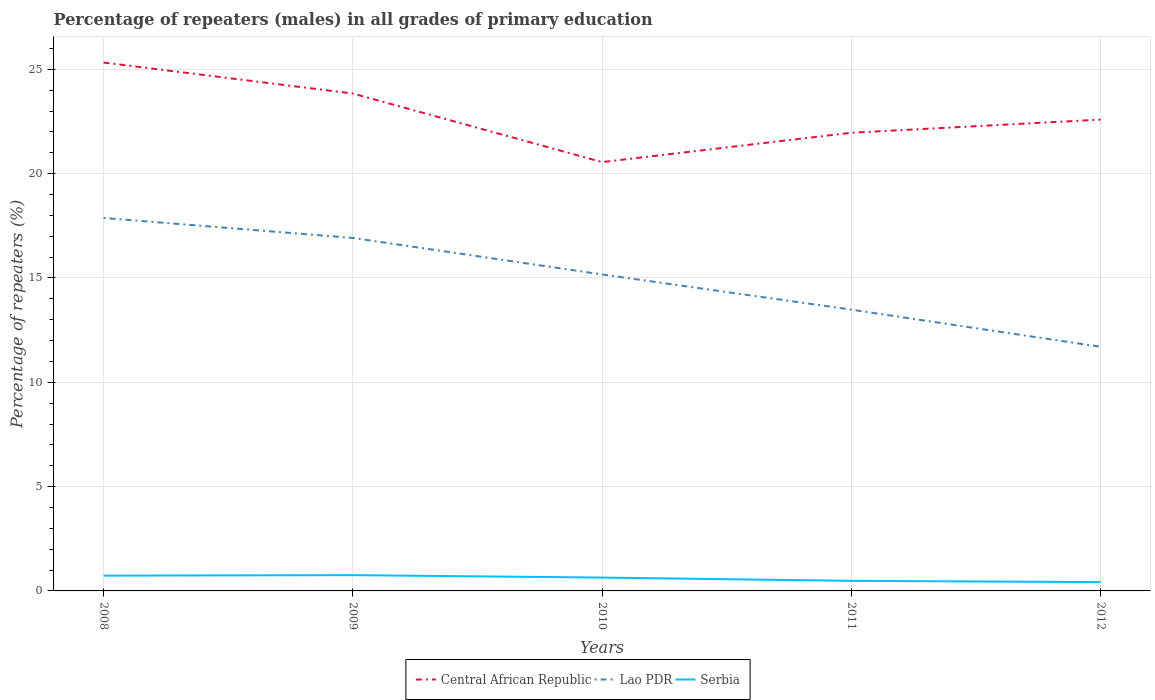Is the number of lines equal to the number of legend labels?
Give a very brief answer. Yes. Across all years, what is the maximum percentage of repeaters (males) in Lao PDR?
Keep it short and to the point. 11.7. What is the total percentage of repeaters (males) in Central African Republic in the graph?
Give a very brief answer. -2.04. What is the difference between the highest and the second highest percentage of repeaters (males) in Central African Republic?
Provide a succinct answer. 4.77. How many lines are there?
Ensure brevity in your answer.  3. How many years are there in the graph?
Offer a very short reply. 5. Are the values on the major ticks of Y-axis written in scientific E-notation?
Give a very brief answer. No. Does the graph contain any zero values?
Ensure brevity in your answer.  No. Does the graph contain grids?
Offer a terse response. Yes. How many legend labels are there?
Offer a terse response. 3. What is the title of the graph?
Make the answer very short. Percentage of repeaters (males) in all grades of primary education. What is the label or title of the X-axis?
Provide a short and direct response. Years. What is the label or title of the Y-axis?
Your answer should be compact. Percentage of repeaters (%). What is the Percentage of repeaters (%) in Central African Republic in 2008?
Offer a very short reply. 25.33. What is the Percentage of repeaters (%) of Lao PDR in 2008?
Give a very brief answer. 17.88. What is the Percentage of repeaters (%) in Serbia in 2008?
Provide a short and direct response. 0.73. What is the Percentage of repeaters (%) of Central African Republic in 2009?
Offer a very short reply. 23.84. What is the Percentage of repeaters (%) of Lao PDR in 2009?
Your response must be concise. 16.92. What is the Percentage of repeaters (%) in Serbia in 2009?
Ensure brevity in your answer.  0.76. What is the Percentage of repeaters (%) in Central African Republic in 2010?
Give a very brief answer. 20.56. What is the Percentage of repeaters (%) in Lao PDR in 2010?
Offer a very short reply. 15.17. What is the Percentage of repeaters (%) in Serbia in 2010?
Provide a succinct answer. 0.64. What is the Percentage of repeaters (%) in Central African Republic in 2011?
Your answer should be very brief. 21.96. What is the Percentage of repeaters (%) of Lao PDR in 2011?
Offer a very short reply. 13.48. What is the Percentage of repeaters (%) of Serbia in 2011?
Make the answer very short. 0.48. What is the Percentage of repeaters (%) of Central African Republic in 2012?
Your response must be concise. 22.59. What is the Percentage of repeaters (%) in Lao PDR in 2012?
Offer a terse response. 11.7. What is the Percentage of repeaters (%) in Serbia in 2012?
Provide a short and direct response. 0.42. Across all years, what is the maximum Percentage of repeaters (%) of Central African Republic?
Provide a succinct answer. 25.33. Across all years, what is the maximum Percentage of repeaters (%) in Lao PDR?
Your answer should be very brief. 17.88. Across all years, what is the maximum Percentage of repeaters (%) of Serbia?
Your response must be concise. 0.76. Across all years, what is the minimum Percentage of repeaters (%) in Central African Republic?
Your answer should be compact. 20.56. Across all years, what is the minimum Percentage of repeaters (%) in Lao PDR?
Provide a short and direct response. 11.7. Across all years, what is the minimum Percentage of repeaters (%) of Serbia?
Provide a succinct answer. 0.42. What is the total Percentage of repeaters (%) of Central African Republic in the graph?
Your answer should be compact. 114.28. What is the total Percentage of repeaters (%) in Lao PDR in the graph?
Offer a very short reply. 75.15. What is the total Percentage of repeaters (%) of Serbia in the graph?
Provide a succinct answer. 3.03. What is the difference between the Percentage of repeaters (%) in Central African Republic in 2008 and that in 2009?
Offer a terse response. 1.48. What is the difference between the Percentage of repeaters (%) of Serbia in 2008 and that in 2009?
Offer a very short reply. -0.02. What is the difference between the Percentage of repeaters (%) of Central African Republic in 2008 and that in 2010?
Make the answer very short. 4.77. What is the difference between the Percentage of repeaters (%) in Lao PDR in 2008 and that in 2010?
Offer a very short reply. 2.71. What is the difference between the Percentage of repeaters (%) of Serbia in 2008 and that in 2010?
Provide a succinct answer. 0.09. What is the difference between the Percentage of repeaters (%) of Central African Republic in 2008 and that in 2011?
Your answer should be compact. 3.36. What is the difference between the Percentage of repeaters (%) of Lao PDR in 2008 and that in 2011?
Ensure brevity in your answer.  4.39. What is the difference between the Percentage of repeaters (%) of Serbia in 2008 and that in 2011?
Ensure brevity in your answer.  0.25. What is the difference between the Percentage of repeaters (%) of Central African Republic in 2008 and that in 2012?
Make the answer very short. 2.73. What is the difference between the Percentage of repeaters (%) of Lao PDR in 2008 and that in 2012?
Your answer should be compact. 6.18. What is the difference between the Percentage of repeaters (%) of Serbia in 2008 and that in 2012?
Offer a very short reply. 0.31. What is the difference between the Percentage of repeaters (%) of Central African Republic in 2009 and that in 2010?
Give a very brief answer. 3.29. What is the difference between the Percentage of repeaters (%) in Lao PDR in 2009 and that in 2010?
Keep it short and to the point. 1.75. What is the difference between the Percentage of repeaters (%) of Serbia in 2009 and that in 2010?
Make the answer very short. 0.12. What is the difference between the Percentage of repeaters (%) of Central African Republic in 2009 and that in 2011?
Make the answer very short. 1.88. What is the difference between the Percentage of repeaters (%) in Lao PDR in 2009 and that in 2011?
Keep it short and to the point. 3.44. What is the difference between the Percentage of repeaters (%) in Serbia in 2009 and that in 2011?
Offer a very short reply. 0.27. What is the difference between the Percentage of repeaters (%) of Central African Republic in 2009 and that in 2012?
Provide a succinct answer. 1.25. What is the difference between the Percentage of repeaters (%) in Lao PDR in 2009 and that in 2012?
Provide a short and direct response. 5.22. What is the difference between the Percentage of repeaters (%) of Serbia in 2009 and that in 2012?
Your answer should be compact. 0.33. What is the difference between the Percentage of repeaters (%) of Central African Republic in 2010 and that in 2011?
Ensure brevity in your answer.  -1.41. What is the difference between the Percentage of repeaters (%) of Lao PDR in 2010 and that in 2011?
Provide a succinct answer. 1.69. What is the difference between the Percentage of repeaters (%) in Serbia in 2010 and that in 2011?
Give a very brief answer. 0.16. What is the difference between the Percentage of repeaters (%) of Central African Republic in 2010 and that in 2012?
Offer a very short reply. -2.04. What is the difference between the Percentage of repeaters (%) of Lao PDR in 2010 and that in 2012?
Your answer should be very brief. 3.47. What is the difference between the Percentage of repeaters (%) of Serbia in 2010 and that in 2012?
Your answer should be very brief. 0.22. What is the difference between the Percentage of repeaters (%) in Central African Republic in 2011 and that in 2012?
Your answer should be compact. -0.63. What is the difference between the Percentage of repeaters (%) of Lao PDR in 2011 and that in 2012?
Offer a terse response. 1.78. What is the difference between the Percentage of repeaters (%) of Serbia in 2011 and that in 2012?
Make the answer very short. 0.06. What is the difference between the Percentage of repeaters (%) in Central African Republic in 2008 and the Percentage of repeaters (%) in Lao PDR in 2009?
Ensure brevity in your answer.  8.41. What is the difference between the Percentage of repeaters (%) of Central African Republic in 2008 and the Percentage of repeaters (%) of Serbia in 2009?
Provide a short and direct response. 24.57. What is the difference between the Percentage of repeaters (%) of Lao PDR in 2008 and the Percentage of repeaters (%) of Serbia in 2009?
Your answer should be very brief. 17.12. What is the difference between the Percentage of repeaters (%) of Central African Republic in 2008 and the Percentage of repeaters (%) of Lao PDR in 2010?
Make the answer very short. 10.16. What is the difference between the Percentage of repeaters (%) in Central African Republic in 2008 and the Percentage of repeaters (%) in Serbia in 2010?
Provide a short and direct response. 24.69. What is the difference between the Percentage of repeaters (%) in Lao PDR in 2008 and the Percentage of repeaters (%) in Serbia in 2010?
Offer a terse response. 17.24. What is the difference between the Percentage of repeaters (%) in Central African Republic in 2008 and the Percentage of repeaters (%) in Lao PDR in 2011?
Offer a very short reply. 11.84. What is the difference between the Percentage of repeaters (%) of Central African Republic in 2008 and the Percentage of repeaters (%) of Serbia in 2011?
Make the answer very short. 24.84. What is the difference between the Percentage of repeaters (%) in Lao PDR in 2008 and the Percentage of repeaters (%) in Serbia in 2011?
Provide a succinct answer. 17.39. What is the difference between the Percentage of repeaters (%) in Central African Republic in 2008 and the Percentage of repeaters (%) in Lao PDR in 2012?
Your response must be concise. 13.62. What is the difference between the Percentage of repeaters (%) in Central African Republic in 2008 and the Percentage of repeaters (%) in Serbia in 2012?
Offer a very short reply. 24.9. What is the difference between the Percentage of repeaters (%) in Lao PDR in 2008 and the Percentage of repeaters (%) in Serbia in 2012?
Ensure brevity in your answer.  17.46. What is the difference between the Percentage of repeaters (%) of Central African Republic in 2009 and the Percentage of repeaters (%) of Lao PDR in 2010?
Your answer should be compact. 8.67. What is the difference between the Percentage of repeaters (%) of Central African Republic in 2009 and the Percentage of repeaters (%) of Serbia in 2010?
Your answer should be very brief. 23.2. What is the difference between the Percentage of repeaters (%) in Lao PDR in 2009 and the Percentage of repeaters (%) in Serbia in 2010?
Your answer should be very brief. 16.28. What is the difference between the Percentage of repeaters (%) of Central African Republic in 2009 and the Percentage of repeaters (%) of Lao PDR in 2011?
Provide a succinct answer. 10.36. What is the difference between the Percentage of repeaters (%) of Central African Republic in 2009 and the Percentage of repeaters (%) of Serbia in 2011?
Provide a short and direct response. 23.36. What is the difference between the Percentage of repeaters (%) in Lao PDR in 2009 and the Percentage of repeaters (%) in Serbia in 2011?
Provide a succinct answer. 16.44. What is the difference between the Percentage of repeaters (%) in Central African Republic in 2009 and the Percentage of repeaters (%) in Lao PDR in 2012?
Keep it short and to the point. 12.14. What is the difference between the Percentage of repeaters (%) of Central African Republic in 2009 and the Percentage of repeaters (%) of Serbia in 2012?
Offer a terse response. 23.42. What is the difference between the Percentage of repeaters (%) of Lao PDR in 2009 and the Percentage of repeaters (%) of Serbia in 2012?
Make the answer very short. 16.5. What is the difference between the Percentage of repeaters (%) in Central African Republic in 2010 and the Percentage of repeaters (%) in Lao PDR in 2011?
Make the answer very short. 7.07. What is the difference between the Percentage of repeaters (%) of Central African Republic in 2010 and the Percentage of repeaters (%) of Serbia in 2011?
Your response must be concise. 20.07. What is the difference between the Percentage of repeaters (%) in Lao PDR in 2010 and the Percentage of repeaters (%) in Serbia in 2011?
Make the answer very short. 14.69. What is the difference between the Percentage of repeaters (%) in Central African Republic in 2010 and the Percentage of repeaters (%) in Lao PDR in 2012?
Your answer should be compact. 8.85. What is the difference between the Percentage of repeaters (%) of Central African Republic in 2010 and the Percentage of repeaters (%) of Serbia in 2012?
Offer a very short reply. 20.13. What is the difference between the Percentage of repeaters (%) of Lao PDR in 2010 and the Percentage of repeaters (%) of Serbia in 2012?
Your response must be concise. 14.75. What is the difference between the Percentage of repeaters (%) of Central African Republic in 2011 and the Percentage of repeaters (%) of Lao PDR in 2012?
Provide a succinct answer. 10.26. What is the difference between the Percentage of repeaters (%) in Central African Republic in 2011 and the Percentage of repeaters (%) in Serbia in 2012?
Keep it short and to the point. 21.54. What is the difference between the Percentage of repeaters (%) in Lao PDR in 2011 and the Percentage of repeaters (%) in Serbia in 2012?
Your answer should be very brief. 13.06. What is the average Percentage of repeaters (%) of Central African Republic per year?
Provide a succinct answer. 22.86. What is the average Percentage of repeaters (%) of Lao PDR per year?
Offer a terse response. 15.03. What is the average Percentage of repeaters (%) in Serbia per year?
Provide a succinct answer. 0.61. In the year 2008, what is the difference between the Percentage of repeaters (%) in Central African Republic and Percentage of repeaters (%) in Lao PDR?
Offer a terse response. 7.45. In the year 2008, what is the difference between the Percentage of repeaters (%) of Central African Republic and Percentage of repeaters (%) of Serbia?
Your answer should be compact. 24.59. In the year 2008, what is the difference between the Percentage of repeaters (%) of Lao PDR and Percentage of repeaters (%) of Serbia?
Make the answer very short. 17.14. In the year 2009, what is the difference between the Percentage of repeaters (%) in Central African Republic and Percentage of repeaters (%) in Lao PDR?
Keep it short and to the point. 6.92. In the year 2009, what is the difference between the Percentage of repeaters (%) in Central African Republic and Percentage of repeaters (%) in Serbia?
Make the answer very short. 23.09. In the year 2009, what is the difference between the Percentage of repeaters (%) of Lao PDR and Percentage of repeaters (%) of Serbia?
Provide a short and direct response. 16.16. In the year 2010, what is the difference between the Percentage of repeaters (%) of Central African Republic and Percentage of repeaters (%) of Lao PDR?
Your answer should be compact. 5.39. In the year 2010, what is the difference between the Percentage of repeaters (%) in Central African Republic and Percentage of repeaters (%) in Serbia?
Give a very brief answer. 19.92. In the year 2010, what is the difference between the Percentage of repeaters (%) in Lao PDR and Percentage of repeaters (%) in Serbia?
Your answer should be very brief. 14.53. In the year 2011, what is the difference between the Percentage of repeaters (%) in Central African Republic and Percentage of repeaters (%) in Lao PDR?
Offer a terse response. 8.48. In the year 2011, what is the difference between the Percentage of repeaters (%) in Central African Republic and Percentage of repeaters (%) in Serbia?
Keep it short and to the point. 21.48. In the year 2011, what is the difference between the Percentage of repeaters (%) in Lao PDR and Percentage of repeaters (%) in Serbia?
Your response must be concise. 13. In the year 2012, what is the difference between the Percentage of repeaters (%) in Central African Republic and Percentage of repeaters (%) in Lao PDR?
Your response must be concise. 10.89. In the year 2012, what is the difference between the Percentage of repeaters (%) in Central African Republic and Percentage of repeaters (%) in Serbia?
Make the answer very short. 22.17. In the year 2012, what is the difference between the Percentage of repeaters (%) in Lao PDR and Percentage of repeaters (%) in Serbia?
Your answer should be compact. 11.28. What is the ratio of the Percentage of repeaters (%) in Central African Republic in 2008 to that in 2009?
Provide a succinct answer. 1.06. What is the ratio of the Percentage of repeaters (%) in Lao PDR in 2008 to that in 2009?
Provide a short and direct response. 1.06. What is the ratio of the Percentage of repeaters (%) of Serbia in 2008 to that in 2009?
Provide a succinct answer. 0.97. What is the ratio of the Percentage of repeaters (%) of Central African Republic in 2008 to that in 2010?
Make the answer very short. 1.23. What is the ratio of the Percentage of repeaters (%) in Lao PDR in 2008 to that in 2010?
Keep it short and to the point. 1.18. What is the ratio of the Percentage of repeaters (%) in Serbia in 2008 to that in 2010?
Offer a terse response. 1.15. What is the ratio of the Percentage of repeaters (%) of Central African Republic in 2008 to that in 2011?
Offer a terse response. 1.15. What is the ratio of the Percentage of repeaters (%) of Lao PDR in 2008 to that in 2011?
Your answer should be very brief. 1.33. What is the ratio of the Percentage of repeaters (%) in Serbia in 2008 to that in 2011?
Keep it short and to the point. 1.52. What is the ratio of the Percentage of repeaters (%) of Central African Republic in 2008 to that in 2012?
Keep it short and to the point. 1.12. What is the ratio of the Percentage of repeaters (%) in Lao PDR in 2008 to that in 2012?
Provide a short and direct response. 1.53. What is the ratio of the Percentage of repeaters (%) in Serbia in 2008 to that in 2012?
Ensure brevity in your answer.  1.74. What is the ratio of the Percentage of repeaters (%) of Central African Republic in 2009 to that in 2010?
Your response must be concise. 1.16. What is the ratio of the Percentage of repeaters (%) in Lao PDR in 2009 to that in 2010?
Offer a very short reply. 1.12. What is the ratio of the Percentage of repeaters (%) of Serbia in 2009 to that in 2010?
Make the answer very short. 1.18. What is the ratio of the Percentage of repeaters (%) of Central African Republic in 2009 to that in 2011?
Offer a very short reply. 1.09. What is the ratio of the Percentage of repeaters (%) in Lao PDR in 2009 to that in 2011?
Offer a very short reply. 1.25. What is the ratio of the Percentage of repeaters (%) in Serbia in 2009 to that in 2011?
Your response must be concise. 1.57. What is the ratio of the Percentage of repeaters (%) in Central African Republic in 2009 to that in 2012?
Provide a short and direct response. 1.06. What is the ratio of the Percentage of repeaters (%) in Lao PDR in 2009 to that in 2012?
Offer a terse response. 1.45. What is the ratio of the Percentage of repeaters (%) in Serbia in 2009 to that in 2012?
Offer a terse response. 1.79. What is the ratio of the Percentage of repeaters (%) of Central African Republic in 2010 to that in 2011?
Keep it short and to the point. 0.94. What is the ratio of the Percentage of repeaters (%) in Lao PDR in 2010 to that in 2011?
Offer a very short reply. 1.13. What is the ratio of the Percentage of repeaters (%) of Serbia in 2010 to that in 2011?
Your response must be concise. 1.32. What is the ratio of the Percentage of repeaters (%) in Central African Republic in 2010 to that in 2012?
Give a very brief answer. 0.91. What is the ratio of the Percentage of repeaters (%) in Lao PDR in 2010 to that in 2012?
Provide a succinct answer. 1.3. What is the ratio of the Percentage of repeaters (%) in Serbia in 2010 to that in 2012?
Make the answer very short. 1.51. What is the ratio of the Percentage of repeaters (%) in Central African Republic in 2011 to that in 2012?
Keep it short and to the point. 0.97. What is the ratio of the Percentage of repeaters (%) in Lao PDR in 2011 to that in 2012?
Provide a succinct answer. 1.15. What is the ratio of the Percentage of repeaters (%) of Serbia in 2011 to that in 2012?
Provide a succinct answer. 1.14. What is the difference between the highest and the second highest Percentage of repeaters (%) of Central African Republic?
Provide a succinct answer. 1.48. What is the difference between the highest and the second highest Percentage of repeaters (%) in Lao PDR?
Offer a terse response. 0.96. What is the difference between the highest and the second highest Percentage of repeaters (%) in Serbia?
Provide a succinct answer. 0.02. What is the difference between the highest and the lowest Percentage of repeaters (%) of Central African Republic?
Make the answer very short. 4.77. What is the difference between the highest and the lowest Percentage of repeaters (%) of Lao PDR?
Your response must be concise. 6.18. What is the difference between the highest and the lowest Percentage of repeaters (%) of Serbia?
Your answer should be compact. 0.33. 